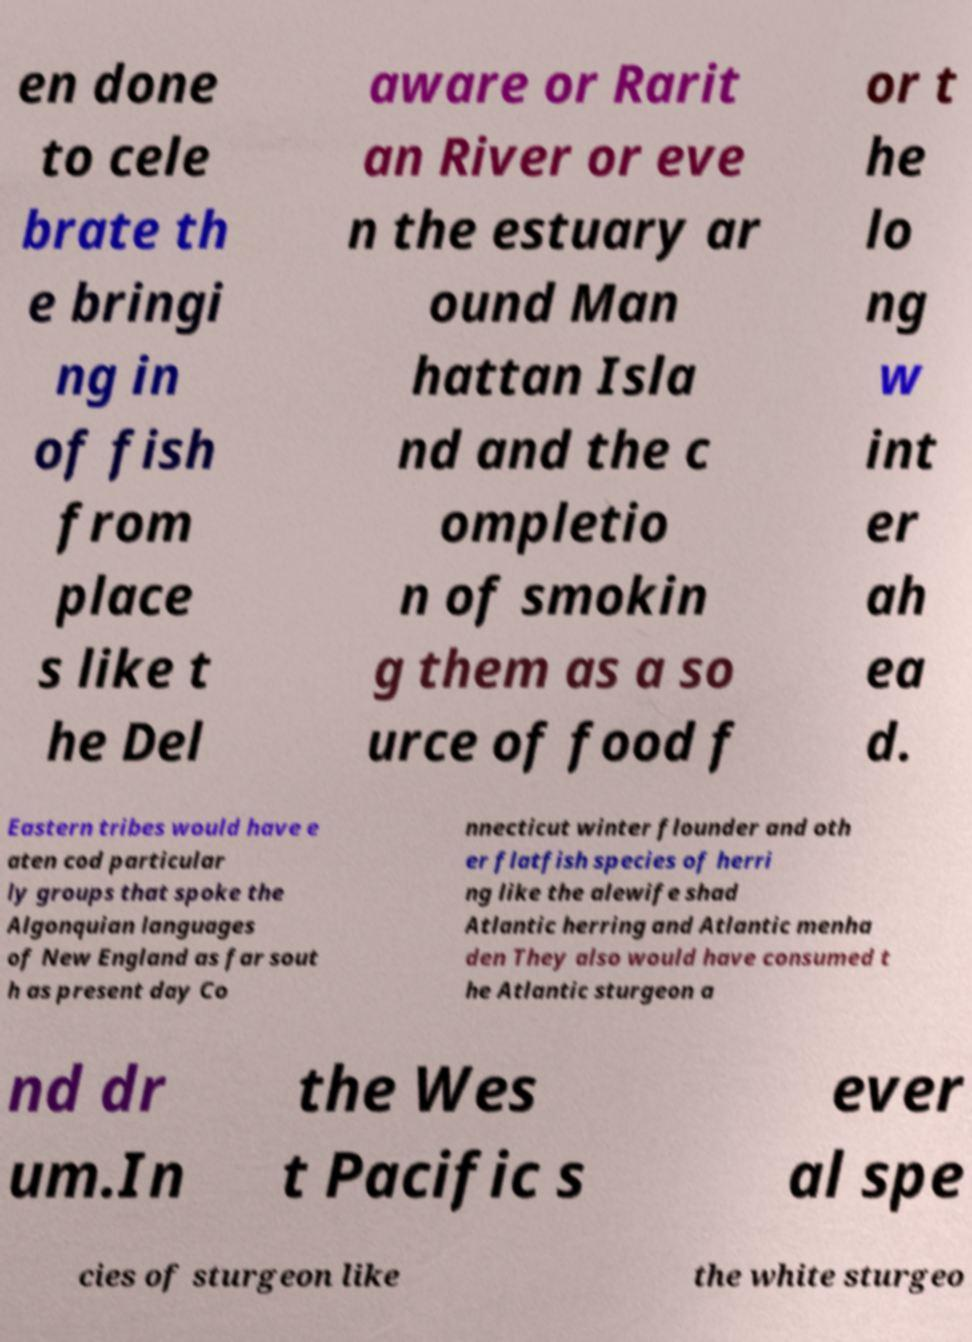Please read and relay the text visible in this image. What does it say? en done to cele brate th e bringi ng in of fish from place s like t he Del aware or Rarit an River or eve n the estuary ar ound Man hattan Isla nd and the c ompletio n of smokin g them as a so urce of food f or t he lo ng w int er ah ea d. Eastern tribes would have e aten cod particular ly groups that spoke the Algonquian languages of New England as far sout h as present day Co nnecticut winter flounder and oth er flatfish species of herri ng like the alewife shad Atlantic herring and Atlantic menha den They also would have consumed t he Atlantic sturgeon a nd dr um.In the Wes t Pacific s ever al spe cies of sturgeon like the white sturgeo 